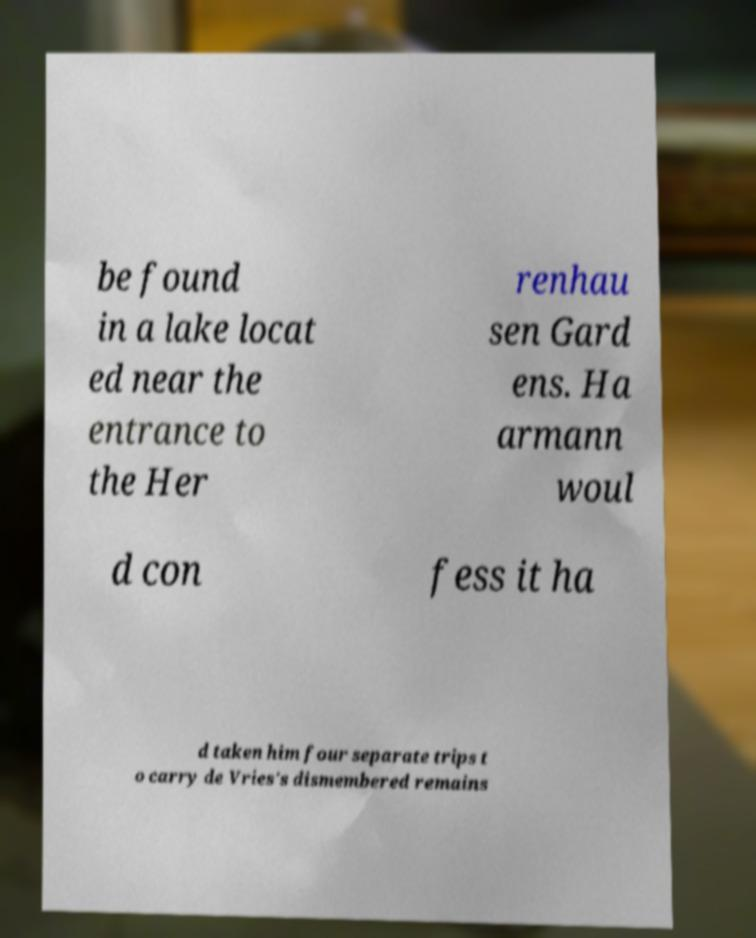What messages or text are displayed in this image? I need them in a readable, typed format. be found in a lake locat ed near the entrance to the Her renhau sen Gard ens. Ha armann woul d con fess it ha d taken him four separate trips t o carry de Vries's dismembered remains 